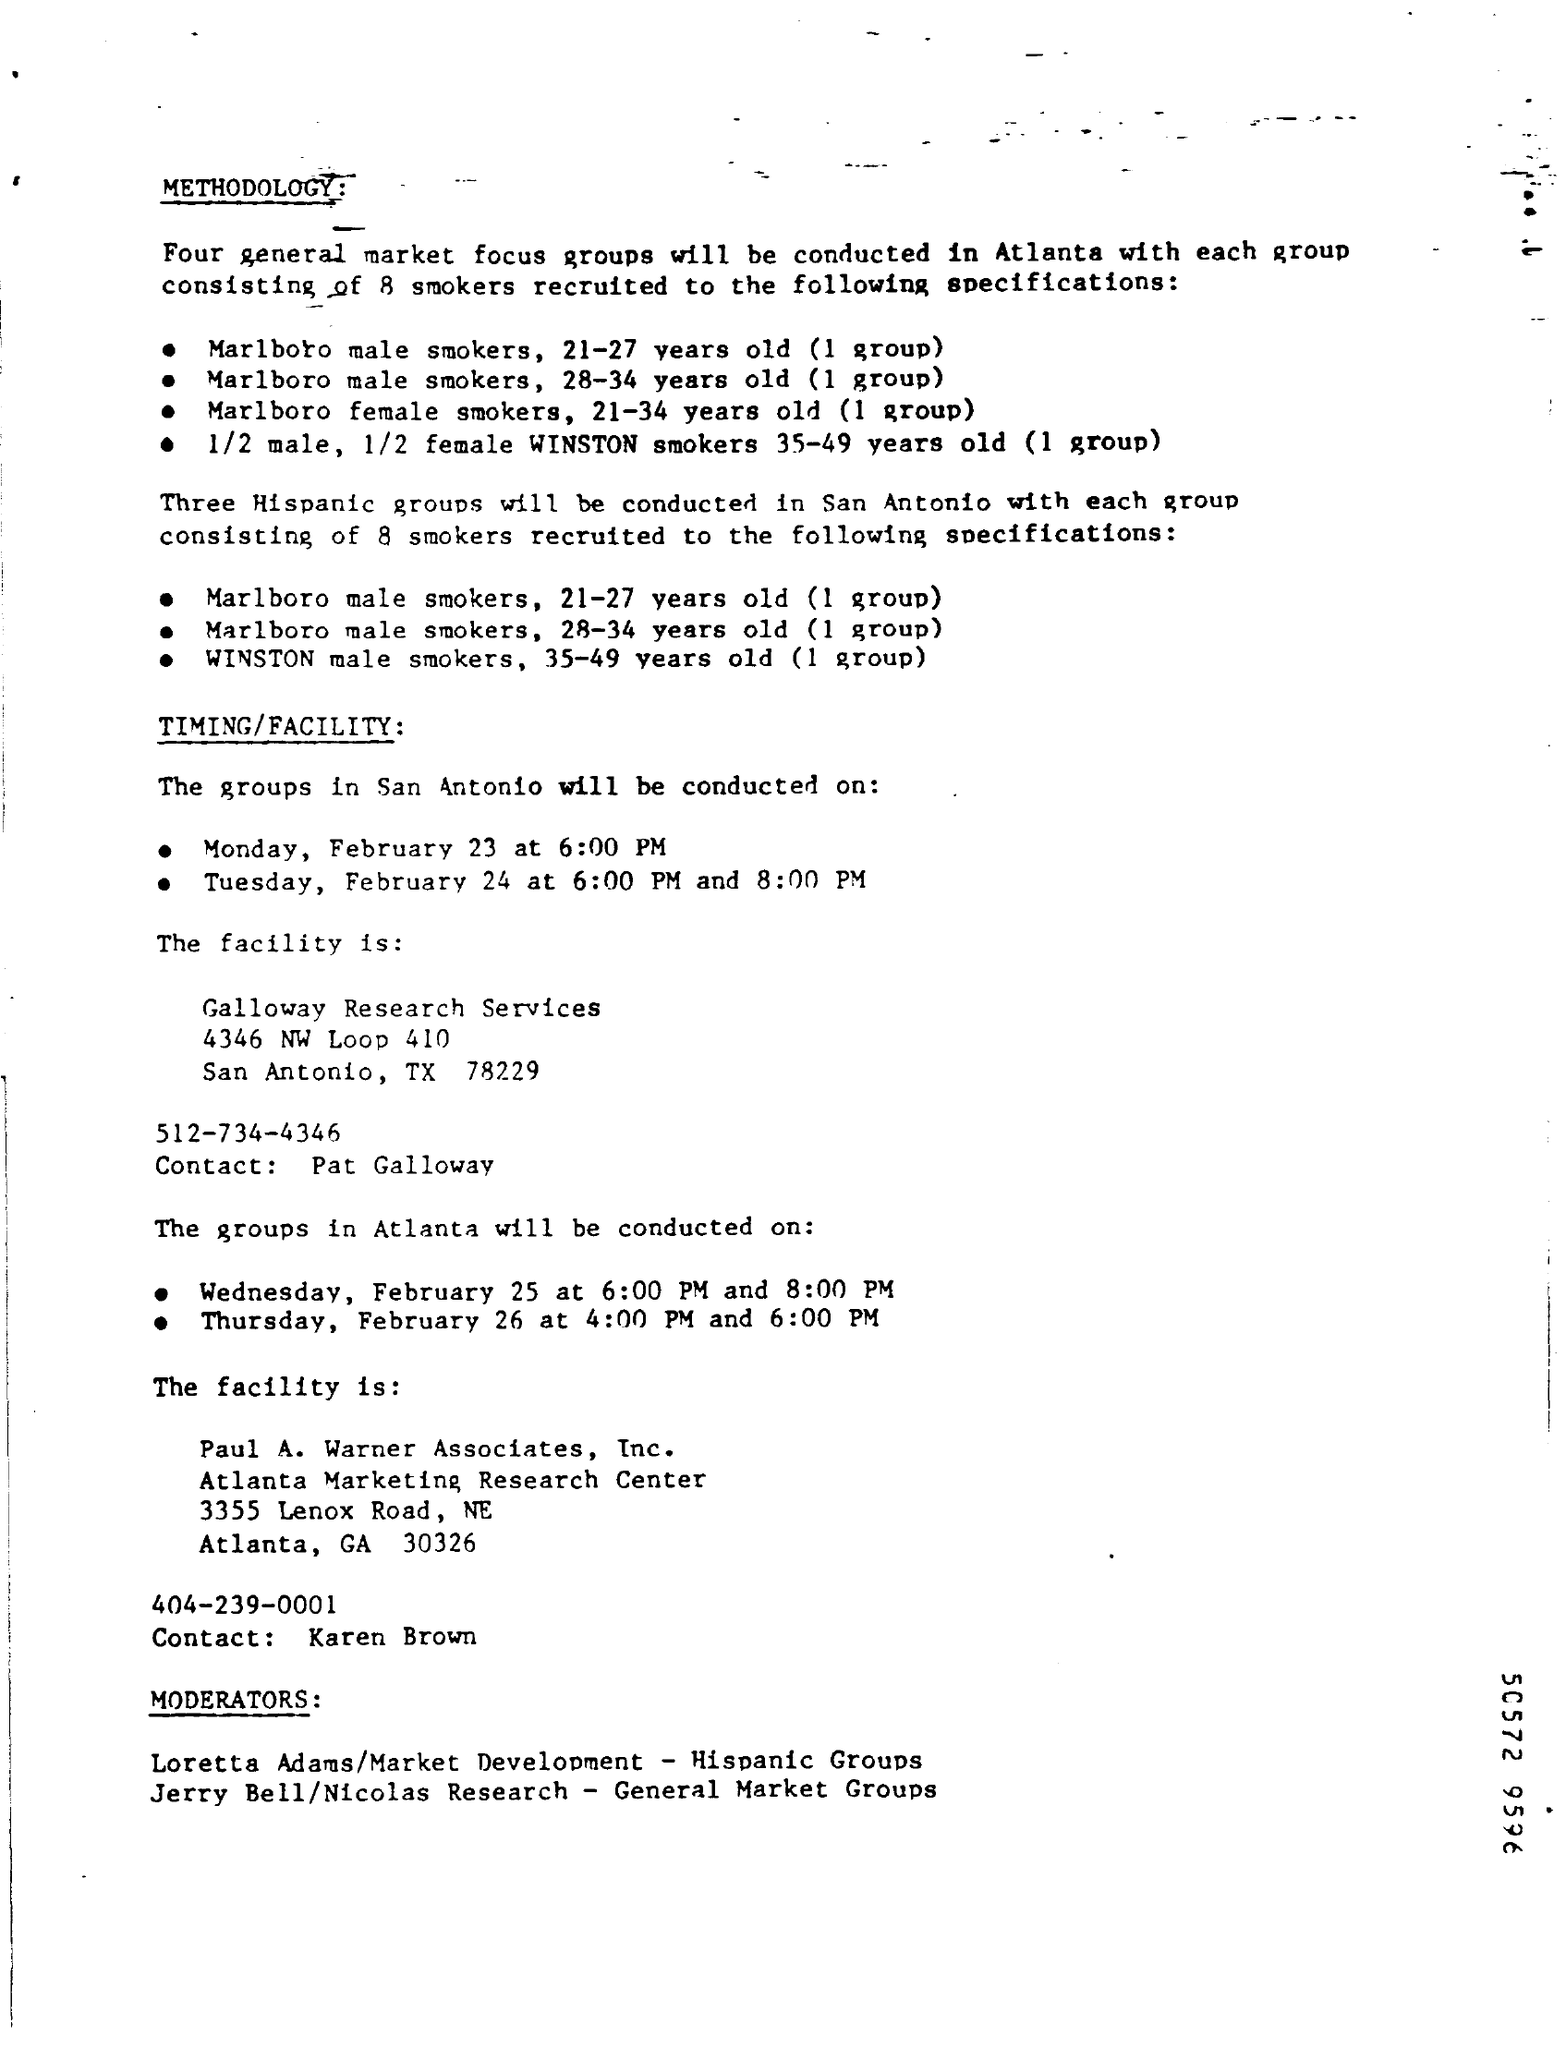What is the age group of winston male smokers ?
Your answer should be very brief. 35-49 years old. At what time the groups in san antonia will be conducted on monday,february 23 ?
Keep it short and to the point. 6:00 PM. 